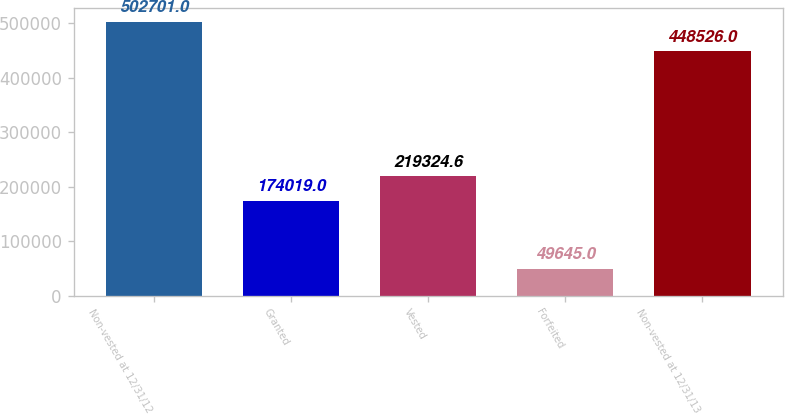Convert chart. <chart><loc_0><loc_0><loc_500><loc_500><bar_chart><fcel>Non-vested at 12/31/12<fcel>Granted<fcel>Vested<fcel>Forfeited<fcel>Non-vested at 12/31/13<nl><fcel>502701<fcel>174019<fcel>219325<fcel>49645<fcel>448526<nl></chart> 